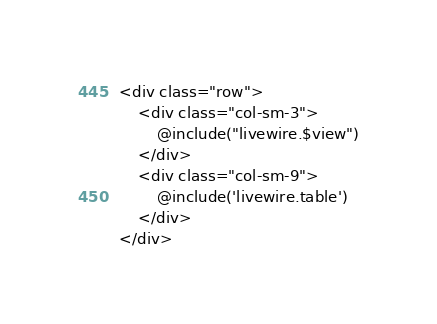<code> <loc_0><loc_0><loc_500><loc_500><_PHP_><div class="row">
    <div class="col-sm-3">
        @include("livewire.$view")
    </div>
    <div class="col-sm-9">
        @include('livewire.table')
    </div>
</div>
</code> 